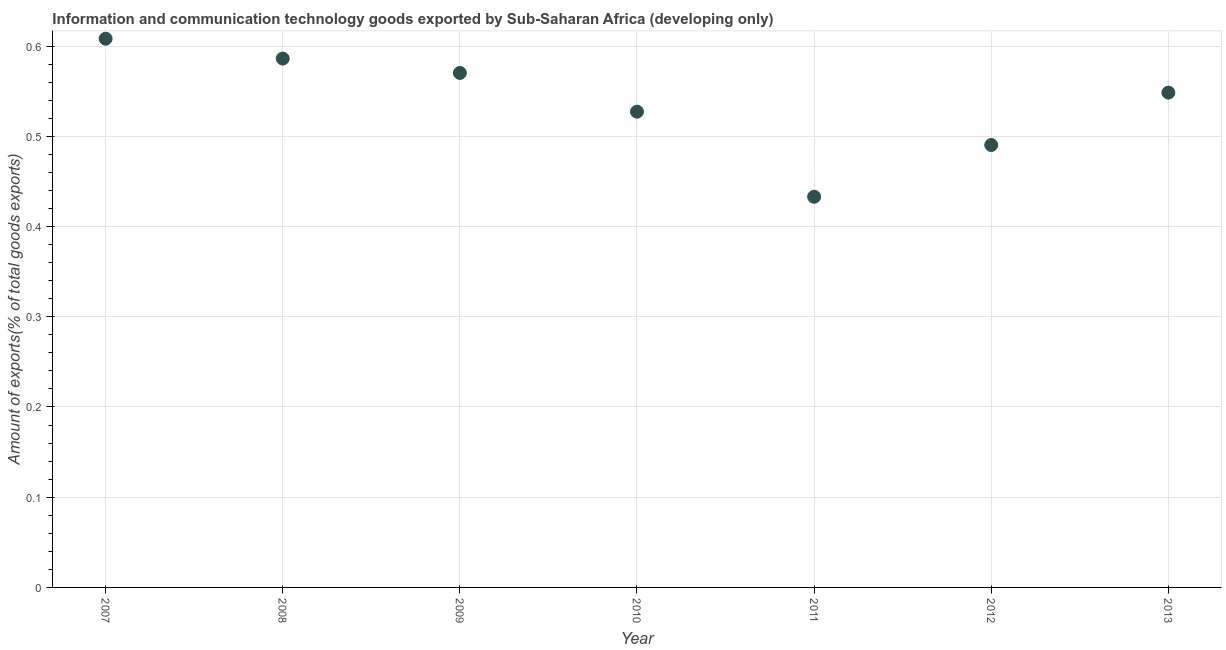What is the amount of ict goods exports in 2012?
Provide a short and direct response. 0.49. Across all years, what is the maximum amount of ict goods exports?
Give a very brief answer. 0.61. Across all years, what is the minimum amount of ict goods exports?
Provide a short and direct response. 0.43. What is the sum of the amount of ict goods exports?
Offer a terse response. 3.76. What is the difference between the amount of ict goods exports in 2010 and 2013?
Keep it short and to the point. -0.02. What is the average amount of ict goods exports per year?
Give a very brief answer. 0.54. What is the median amount of ict goods exports?
Your response must be concise. 0.55. What is the ratio of the amount of ict goods exports in 2010 to that in 2012?
Provide a short and direct response. 1.08. Is the amount of ict goods exports in 2007 less than that in 2012?
Your response must be concise. No. What is the difference between the highest and the second highest amount of ict goods exports?
Keep it short and to the point. 0.02. What is the difference between the highest and the lowest amount of ict goods exports?
Your response must be concise. 0.18. In how many years, is the amount of ict goods exports greater than the average amount of ict goods exports taken over all years?
Offer a terse response. 4. How many dotlines are there?
Your response must be concise. 1. Are the values on the major ticks of Y-axis written in scientific E-notation?
Your answer should be very brief. No. Does the graph contain any zero values?
Keep it short and to the point. No. Does the graph contain grids?
Your answer should be compact. Yes. What is the title of the graph?
Provide a succinct answer. Information and communication technology goods exported by Sub-Saharan Africa (developing only). What is the label or title of the Y-axis?
Provide a succinct answer. Amount of exports(% of total goods exports). What is the Amount of exports(% of total goods exports) in 2007?
Provide a succinct answer. 0.61. What is the Amount of exports(% of total goods exports) in 2008?
Offer a terse response. 0.59. What is the Amount of exports(% of total goods exports) in 2009?
Offer a terse response. 0.57. What is the Amount of exports(% of total goods exports) in 2010?
Give a very brief answer. 0.53. What is the Amount of exports(% of total goods exports) in 2011?
Your answer should be compact. 0.43. What is the Amount of exports(% of total goods exports) in 2012?
Provide a succinct answer. 0.49. What is the Amount of exports(% of total goods exports) in 2013?
Give a very brief answer. 0.55. What is the difference between the Amount of exports(% of total goods exports) in 2007 and 2008?
Make the answer very short. 0.02. What is the difference between the Amount of exports(% of total goods exports) in 2007 and 2009?
Give a very brief answer. 0.04. What is the difference between the Amount of exports(% of total goods exports) in 2007 and 2010?
Provide a short and direct response. 0.08. What is the difference between the Amount of exports(% of total goods exports) in 2007 and 2011?
Your response must be concise. 0.18. What is the difference between the Amount of exports(% of total goods exports) in 2007 and 2012?
Make the answer very short. 0.12. What is the difference between the Amount of exports(% of total goods exports) in 2007 and 2013?
Provide a short and direct response. 0.06. What is the difference between the Amount of exports(% of total goods exports) in 2008 and 2009?
Your response must be concise. 0.02. What is the difference between the Amount of exports(% of total goods exports) in 2008 and 2010?
Give a very brief answer. 0.06. What is the difference between the Amount of exports(% of total goods exports) in 2008 and 2011?
Provide a short and direct response. 0.15. What is the difference between the Amount of exports(% of total goods exports) in 2008 and 2012?
Your response must be concise. 0.1. What is the difference between the Amount of exports(% of total goods exports) in 2008 and 2013?
Provide a succinct answer. 0.04. What is the difference between the Amount of exports(% of total goods exports) in 2009 and 2010?
Your response must be concise. 0.04. What is the difference between the Amount of exports(% of total goods exports) in 2009 and 2011?
Make the answer very short. 0.14. What is the difference between the Amount of exports(% of total goods exports) in 2009 and 2012?
Give a very brief answer. 0.08. What is the difference between the Amount of exports(% of total goods exports) in 2009 and 2013?
Your answer should be compact. 0.02. What is the difference between the Amount of exports(% of total goods exports) in 2010 and 2011?
Offer a terse response. 0.09. What is the difference between the Amount of exports(% of total goods exports) in 2010 and 2012?
Ensure brevity in your answer.  0.04. What is the difference between the Amount of exports(% of total goods exports) in 2010 and 2013?
Your response must be concise. -0.02. What is the difference between the Amount of exports(% of total goods exports) in 2011 and 2012?
Keep it short and to the point. -0.06. What is the difference between the Amount of exports(% of total goods exports) in 2011 and 2013?
Ensure brevity in your answer.  -0.12. What is the difference between the Amount of exports(% of total goods exports) in 2012 and 2013?
Offer a terse response. -0.06. What is the ratio of the Amount of exports(% of total goods exports) in 2007 to that in 2008?
Keep it short and to the point. 1.04. What is the ratio of the Amount of exports(% of total goods exports) in 2007 to that in 2009?
Make the answer very short. 1.07. What is the ratio of the Amount of exports(% of total goods exports) in 2007 to that in 2010?
Keep it short and to the point. 1.15. What is the ratio of the Amount of exports(% of total goods exports) in 2007 to that in 2011?
Make the answer very short. 1.41. What is the ratio of the Amount of exports(% of total goods exports) in 2007 to that in 2012?
Give a very brief answer. 1.24. What is the ratio of the Amount of exports(% of total goods exports) in 2007 to that in 2013?
Ensure brevity in your answer.  1.11. What is the ratio of the Amount of exports(% of total goods exports) in 2008 to that in 2009?
Your answer should be very brief. 1.03. What is the ratio of the Amount of exports(% of total goods exports) in 2008 to that in 2010?
Your answer should be compact. 1.11. What is the ratio of the Amount of exports(% of total goods exports) in 2008 to that in 2011?
Provide a succinct answer. 1.35. What is the ratio of the Amount of exports(% of total goods exports) in 2008 to that in 2012?
Give a very brief answer. 1.2. What is the ratio of the Amount of exports(% of total goods exports) in 2008 to that in 2013?
Offer a very short reply. 1.07. What is the ratio of the Amount of exports(% of total goods exports) in 2009 to that in 2010?
Provide a short and direct response. 1.08. What is the ratio of the Amount of exports(% of total goods exports) in 2009 to that in 2011?
Offer a very short reply. 1.32. What is the ratio of the Amount of exports(% of total goods exports) in 2009 to that in 2012?
Provide a succinct answer. 1.16. What is the ratio of the Amount of exports(% of total goods exports) in 2009 to that in 2013?
Ensure brevity in your answer.  1.04. What is the ratio of the Amount of exports(% of total goods exports) in 2010 to that in 2011?
Your answer should be compact. 1.22. What is the ratio of the Amount of exports(% of total goods exports) in 2010 to that in 2012?
Provide a short and direct response. 1.07. What is the ratio of the Amount of exports(% of total goods exports) in 2011 to that in 2012?
Your response must be concise. 0.88. What is the ratio of the Amount of exports(% of total goods exports) in 2011 to that in 2013?
Offer a terse response. 0.79. What is the ratio of the Amount of exports(% of total goods exports) in 2012 to that in 2013?
Offer a very short reply. 0.89. 